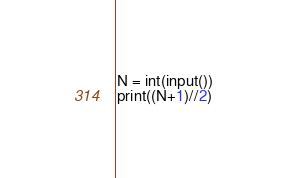Convert code to text. <code><loc_0><loc_0><loc_500><loc_500><_Python_>N = int(input())
print((N+1)//2)
</code> 